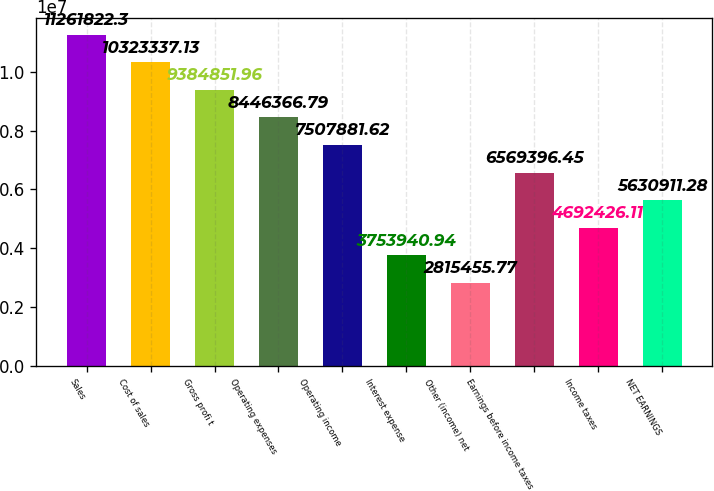<chart> <loc_0><loc_0><loc_500><loc_500><bar_chart><fcel>Sales<fcel>Cost of sales<fcel>Gross profi t<fcel>Operating expenses<fcel>Operating income<fcel>Interest expense<fcel>Other (income) net<fcel>Earnings before income taxes<fcel>Income taxes<fcel>NET EARNINGS<nl><fcel>1.12618e+07<fcel>1.03233e+07<fcel>9.38485e+06<fcel>8.44637e+06<fcel>7.50788e+06<fcel>3.75394e+06<fcel>2.81546e+06<fcel>6.5694e+06<fcel>4.69243e+06<fcel>5.63091e+06<nl></chart> 